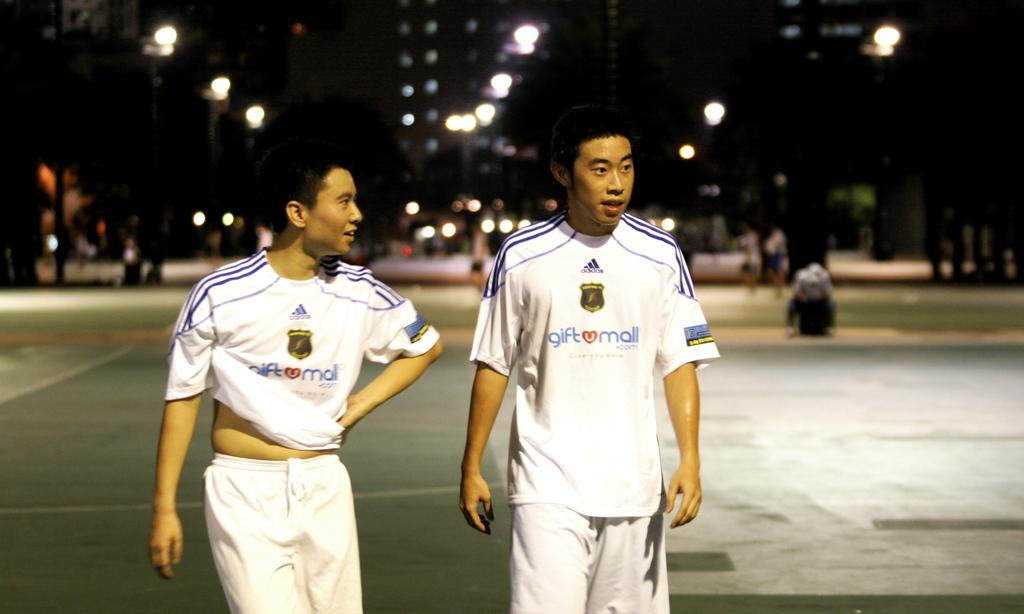<image>
Describe the image concisely. Two soccer players with white Gift Mall jerseys on walk around in the dark with lights on in the back. 